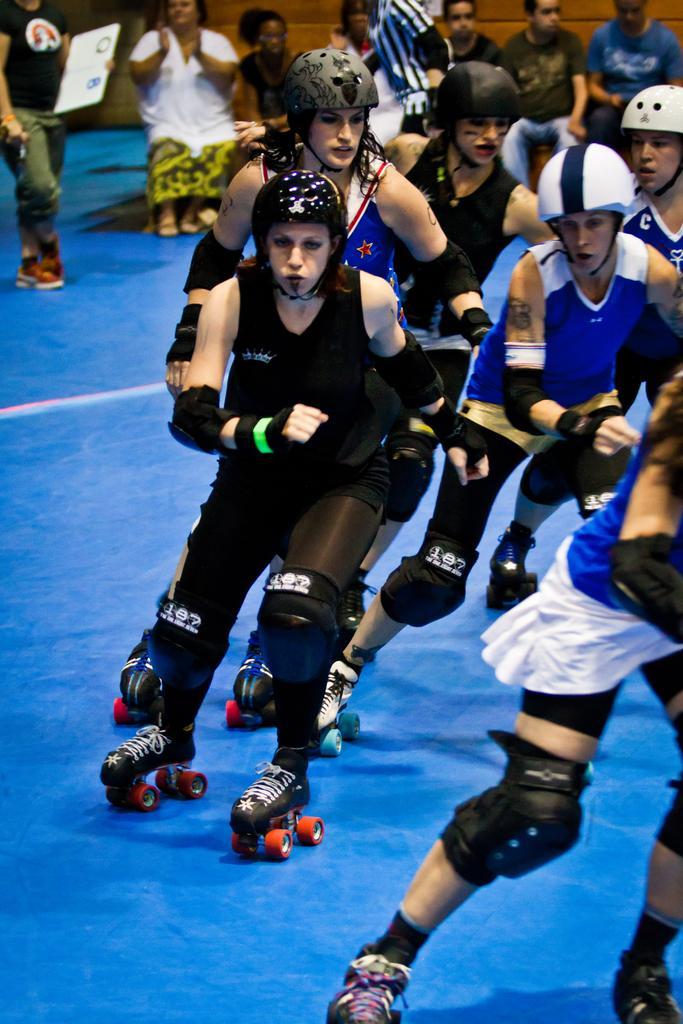How would you summarize this image in a sentence or two? In this image I can see the group of people with dresses and helmets. I can see the see people with the skating shoes. In the background I can see few more people and one person holding the board. I can see the brown color background. 